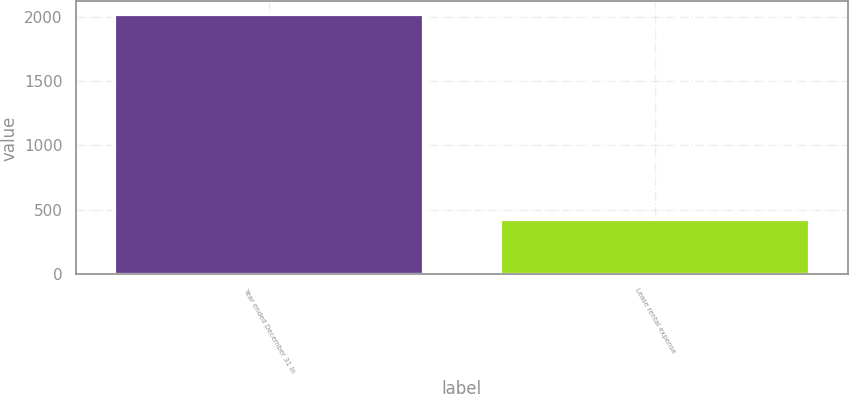Convert chart. <chart><loc_0><loc_0><loc_500><loc_500><bar_chart><fcel>Year ended December 31 In<fcel>Lease rental expense<nl><fcel>2017<fcel>431<nl></chart> 